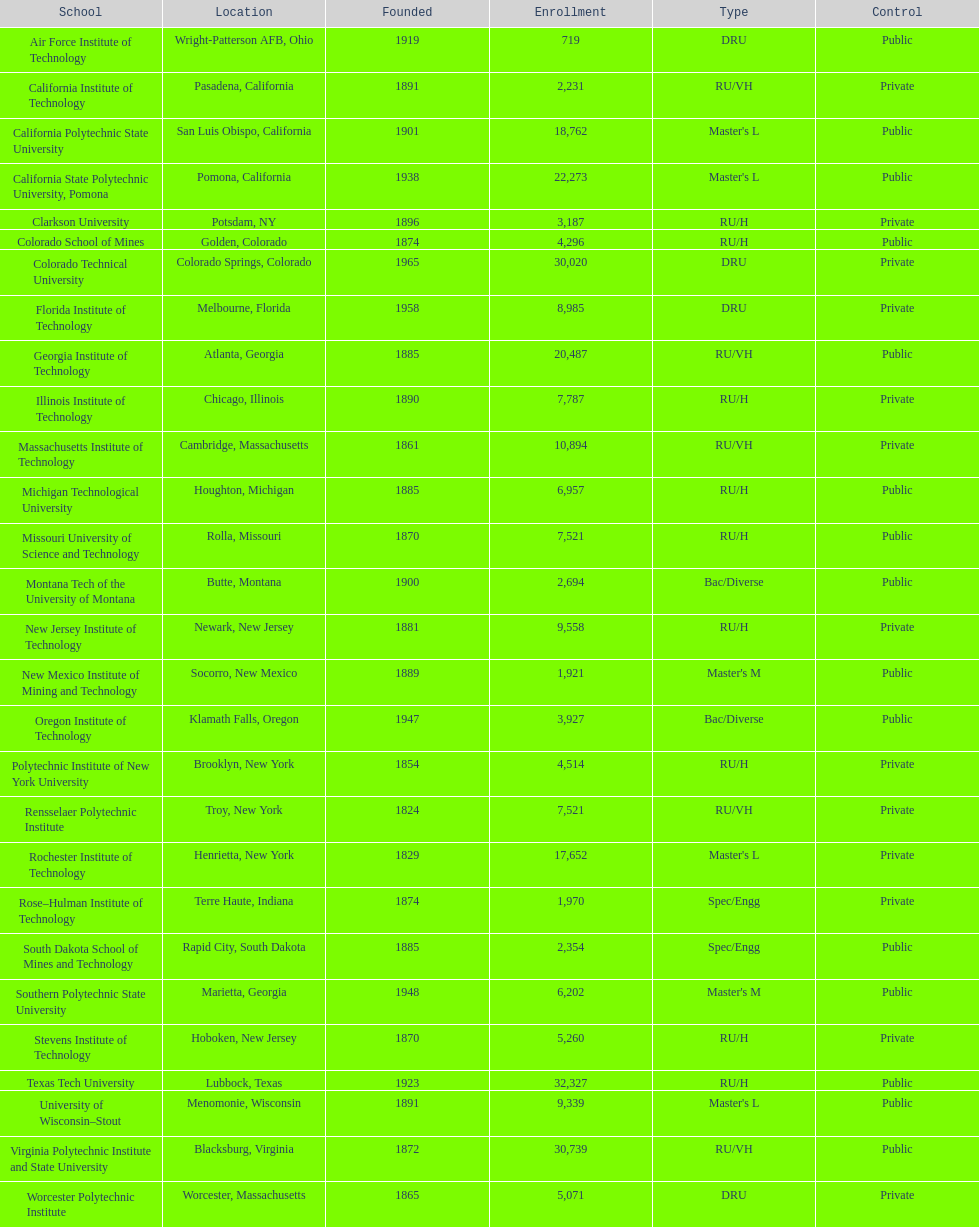Give me the full table as a dictionary. {'header': ['School', 'Location', 'Founded', 'Enrollment', 'Type', 'Control'], 'rows': [['Air Force Institute of Technology', 'Wright-Patterson AFB, Ohio', '1919', '719', 'DRU', 'Public'], ['California Institute of Technology', 'Pasadena, California', '1891', '2,231', 'RU/VH', 'Private'], ['California Polytechnic State University', 'San Luis Obispo, California', '1901', '18,762', "Master's L", 'Public'], ['California State Polytechnic University, Pomona', 'Pomona, California', '1938', '22,273', "Master's L", 'Public'], ['Clarkson University', 'Potsdam, NY', '1896', '3,187', 'RU/H', 'Private'], ['Colorado School of Mines', 'Golden, Colorado', '1874', '4,296', 'RU/H', 'Public'], ['Colorado Technical University', 'Colorado Springs, Colorado', '1965', '30,020', 'DRU', 'Private'], ['Florida Institute of Technology', 'Melbourne, Florida', '1958', '8,985', 'DRU', 'Private'], ['Georgia Institute of Technology', 'Atlanta, Georgia', '1885', '20,487', 'RU/VH', 'Public'], ['Illinois Institute of Technology', 'Chicago, Illinois', '1890', '7,787', 'RU/H', 'Private'], ['Massachusetts Institute of Technology', 'Cambridge, Massachusetts', '1861', '10,894', 'RU/VH', 'Private'], ['Michigan Technological University', 'Houghton, Michigan', '1885', '6,957', 'RU/H', 'Public'], ['Missouri University of Science and Technology', 'Rolla, Missouri', '1870', '7,521', 'RU/H', 'Public'], ['Montana Tech of the University of Montana', 'Butte, Montana', '1900', '2,694', 'Bac/Diverse', 'Public'], ['New Jersey Institute of Technology', 'Newark, New Jersey', '1881', '9,558', 'RU/H', 'Private'], ['New Mexico Institute of Mining and Technology', 'Socorro, New Mexico', '1889', '1,921', "Master's M", 'Public'], ['Oregon Institute of Technology', 'Klamath Falls, Oregon', '1947', '3,927', 'Bac/Diverse', 'Public'], ['Polytechnic Institute of New York University', 'Brooklyn, New York', '1854', '4,514', 'RU/H', 'Private'], ['Rensselaer Polytechnic Institute', 'Troy, New York', '1824', '7,521', 'RU/VH', 'Private'], ['Rochester Institute of Technology', 'Henrietta, New York', '1829', '17,652', "Master's L", 'Private'], ['Rose–Hulman Institute of Technology', 'Terre Haute, Indiana', '1874', '1,970', 'Spec/Engg', 'Private'], ['South Dakota School of Mines and Technology', 'Rapid City, South Dakota', '1885', '2,354', 'Spec/Engg', 'Public'], ['Southern Polytechnic State University', 'Marietta, Georgia', '1948', '6,202', "Master's M", 'Public'], ['Stevens Institute of Technology', 'Hoboken, New Jersey', '1870', '5,260', 'RU/H', 'Private'], ['Texas Tech University', 'Lubbock, Texas', '1923', '32,327', 'RU/H', 'Public'], ['University of Wisconsin–Stout', 'Menomonie, Wisconsin', '1891', '9,339', "Master's L", 'Public'], ['Virginia Polytechnic Institute and State University', 'Blacksburg, Virginia', '1872', '30,739', 'RU/VH', 'Public'], ['Worcester Polytechnic Institute', 'Worcester, Massachusetts', '1865', '5,071', 'DRU', 'Private']]} Which school had the largest enrollment? Texas Tech University. 